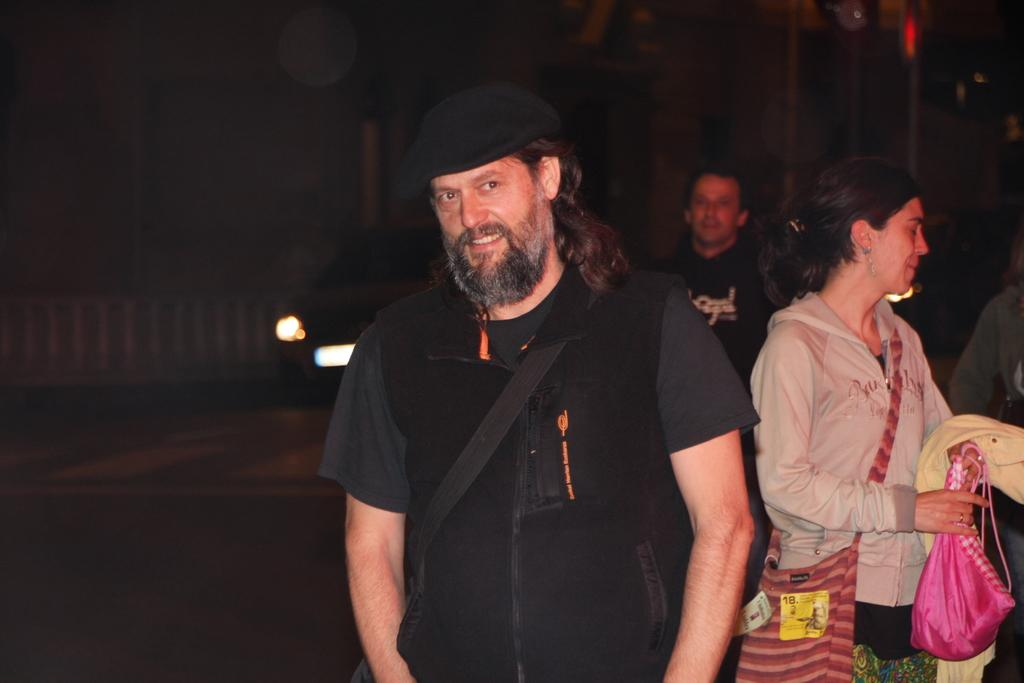How many people are in the image? There are people in the image, but the exact number is not specified. What is one person wearing in the image? One person is wearing a cap in the image. What is one person carrying in the image? One person is carrying a bag in the image. What is another person holding in the image? Another person is holding bags in the image. What can be observed about the background of the image? The background of the image is dark. What type of vehicle is present in the image? There is a vehicle in the image, but its specific type is not mentioned. How does the person wearing the cap feel about the loss of the bridge in the image? There is no bridge present in the image, and therefore no loss of a bridge can be observed. 